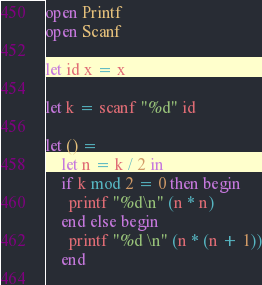Convert code to text. <code><loc_0><loc_0><loc_500><loc_500><_OCaml_>open Printf
open Scanf

let id x = x

let k = scanf "%d" id

let () =
    let n = k / 2 in
    if k mod 2 = 0 then begin
      printf "%d\n" (n * n)
    end else begin
      printf "%d \n" (n * (n + 1))
    end
    </code> 